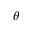<formula> <loc_0><loc_0><loc_500><loc_500>\theta</formula> 